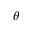<formula> <loc_0><loc_0><loc_500><loc_500>\theta</formula> 